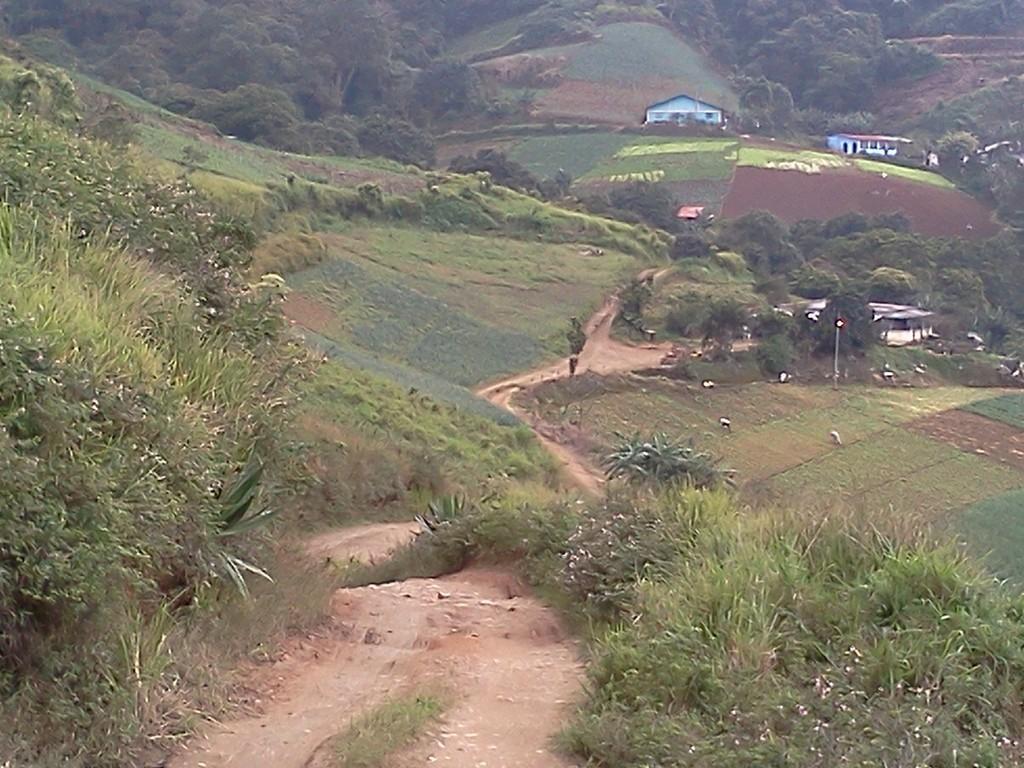How would you summarize this image in a sentence or two? In this image we can see buildings on the hills, persons standing on the agricultural farms, shrubs, bushes and trees. 